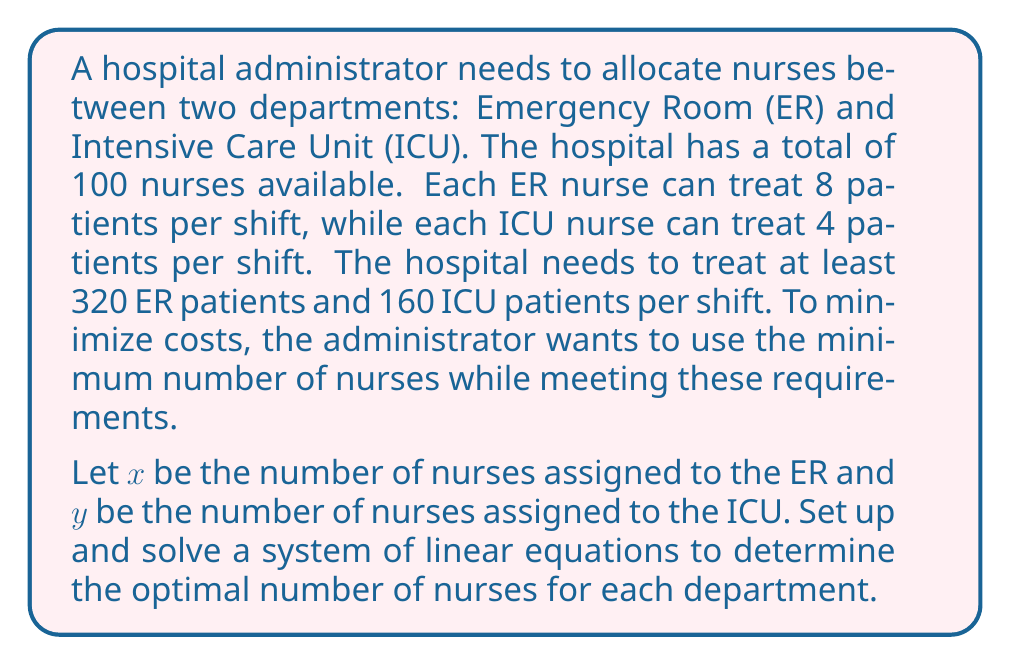Solve this math problem. To solve this problem, we need to set up a system of linear equations based on the given information:

1. Total number of nurses constraint:
   $x + y = 100$

2. ER patient treatment constraint:
   $8x \geq 320$

3. ICU patient treatment constraint:
   $4y \geq 160$

We can simplify the inequalities:
$x \geq 40$ and $y \geq 40$

Since we want to minimize the total number of nurses while meeting both requirements, we can treat these inequalities as equations:

$x = 40$ and $y = 40$

Now, let's verify if this solution satisfies the total nurse constraint:
$40 + 40 = 80$, which is less than or equal to 100, so it satisfies the constraint.

Therefore, the optimal solution is to assign 40 nurses to the ER and 40 nurses to the ICU, for a total of 80 nurses.

This solution:
1. Meets the minimum requirement for ER patients: $8 * 40 = 320$
2. Meets the minimum requirement for ICU patients: $4 * 40 = 160$
3. Uses the minimum number of nurses possible while satisfying all constraints
Answer: The optimal allocation is 40 nurses for the ER and 40 nurses for the ICU, using a total of 80 nurses. 